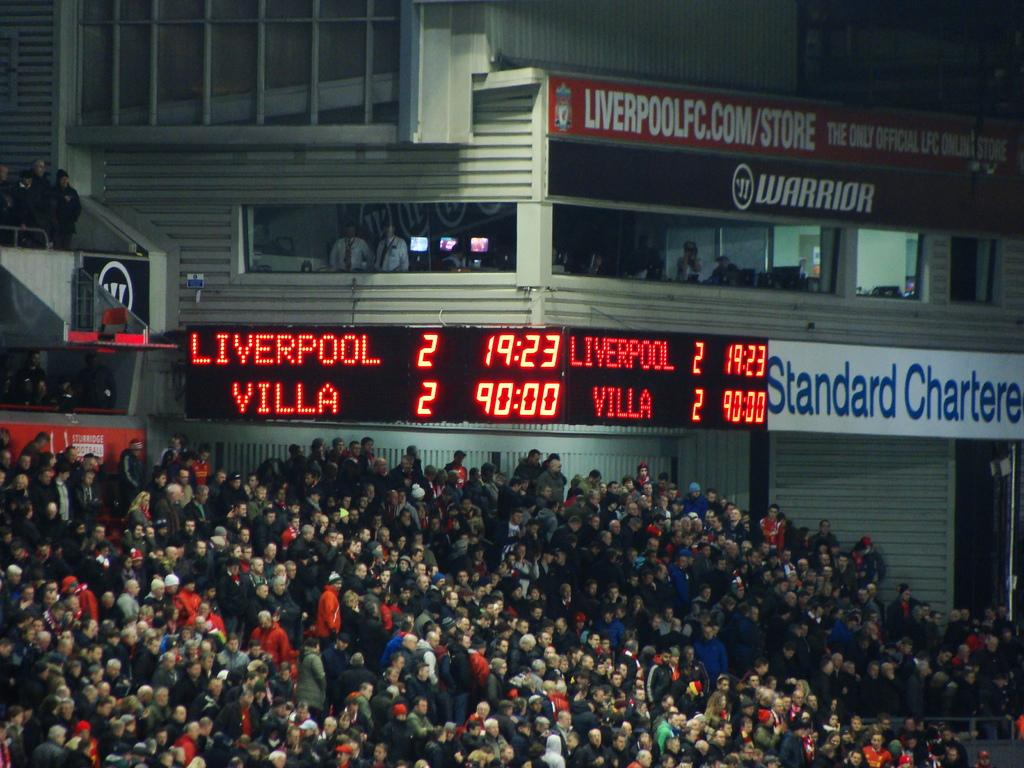<image>
Render a clear and concise summary of the photo. Stadium full of spectators at a sporting event featuring Liverpool and Villa with a tied score. 